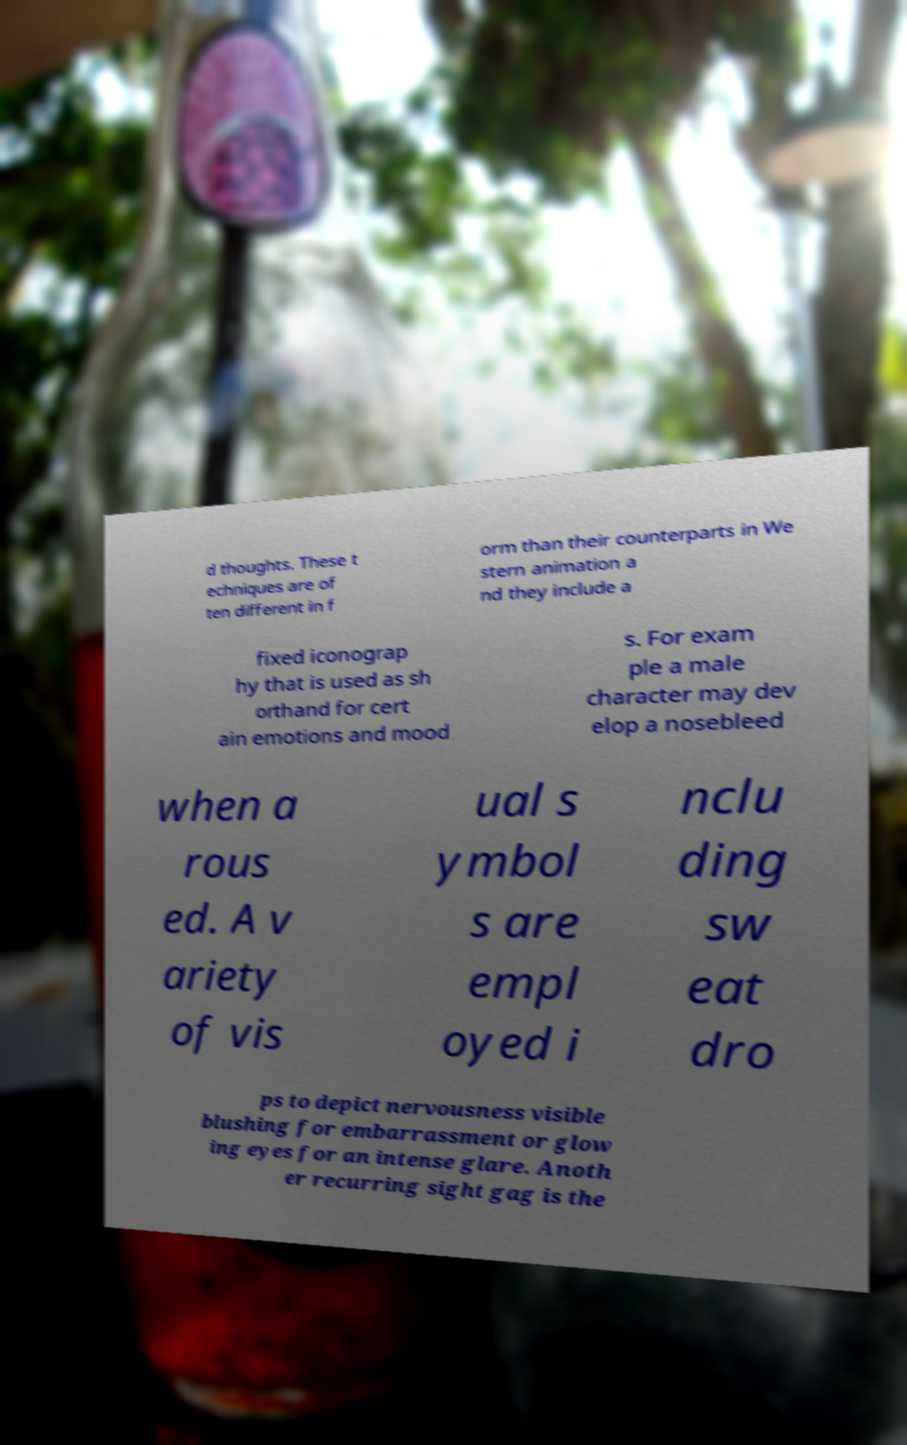Can you read and provide the text displayed in the image?This photo seems to have some interesting text. Can you extract and type it out for me? d thoughts. These t echniques are of ten different in f orm than their counterparts in We stern animation a nd they include a fixed iconograp hy that is used as sh orthand for cert ain emotions and mood s. For exam ple a male character may dev elop a nosebleed when a rous ed. A v ariety of vis ual s ymbol s are empl oyed i nclu ding sw eat dro ps to depict nervousness visible blushing for embarrassment or glow ing eyes for an intense glare. Anoth er recurring sight gag is the 